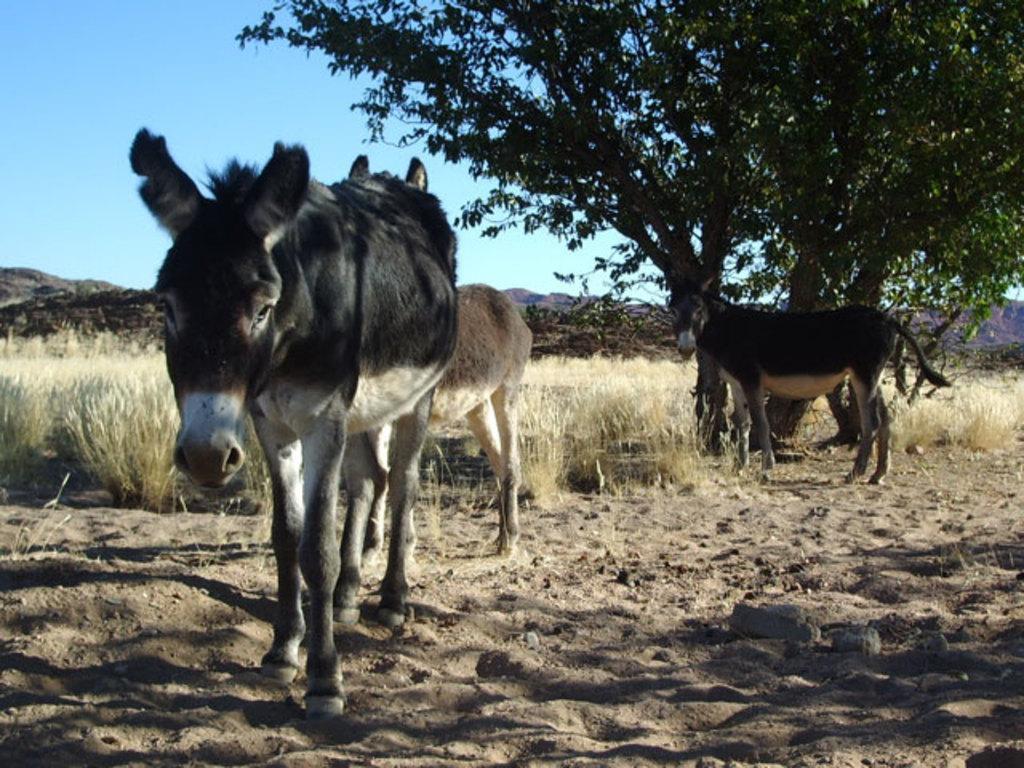Can you describe this image briefly? In this image we can see some horses on the ground. We can also see some plants, a tree, the hills and the sky which looks cloudy. 